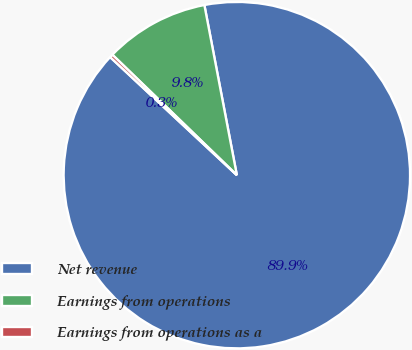Convert chart to OTSL. <chart><loc_0><loc_0><loc_500><loc_500><pie_chart><fcel>Net revenue<fcel>Earnings from operations<fcel>Earnings from operations as a<nl><fcel>89.94%<fcel>9.76%<fcel>0.3%<nl></chart> 